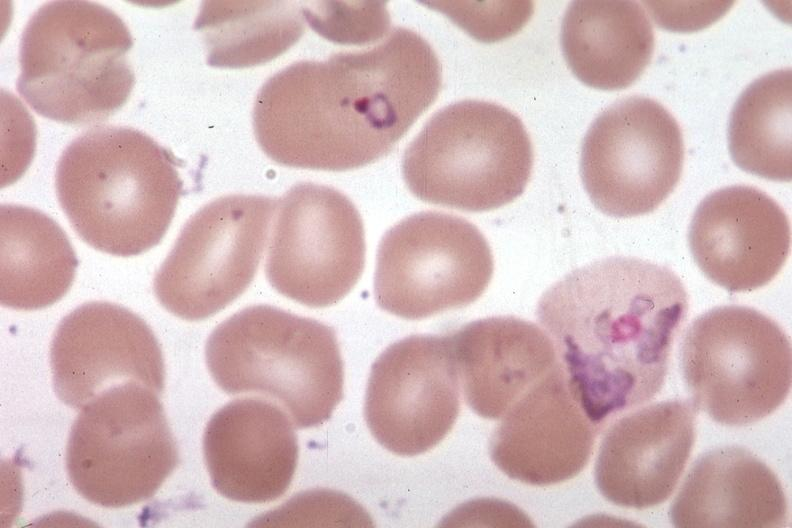what is present?
Answer the question using a single word or phrase. Blood 